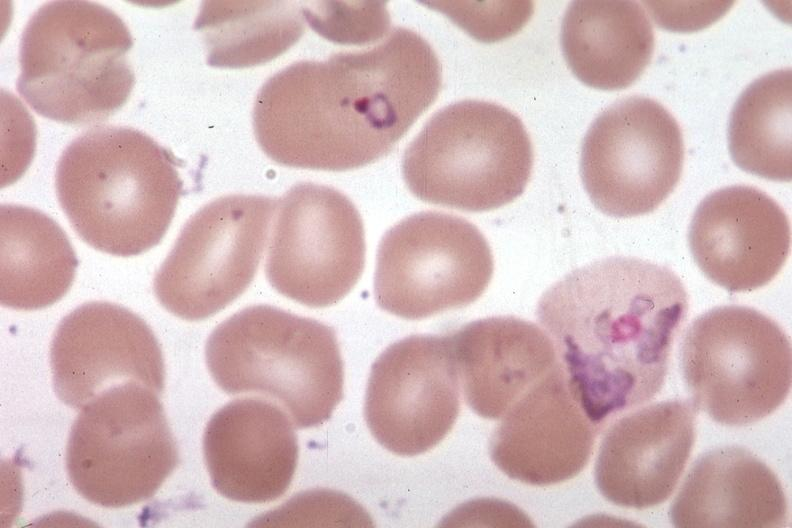what is present?
Answer the question using a single word or phrase. Blood 